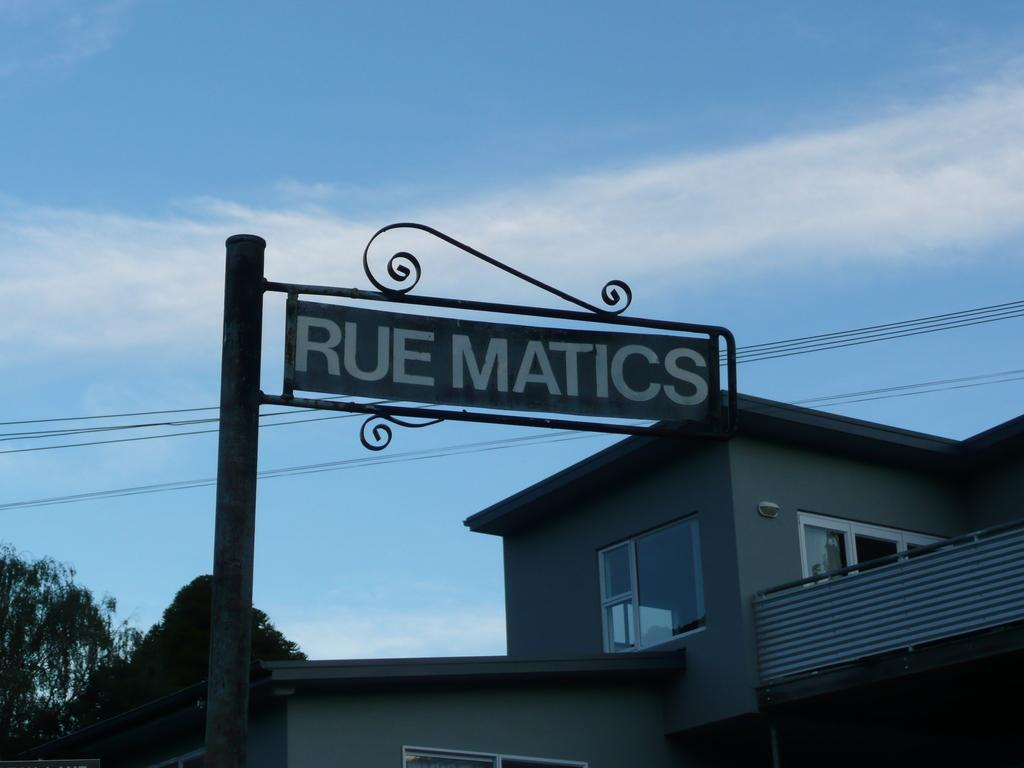What is located in the foreground of the image? There is a pole in the foreground of the image. What structure is visible behind the pole? There is a house behind the pole. What type of vegetation can be seen in the image? Trees are visible in the image. What else is present in the image besides the pole, house, and trees? Cables are present in the image. What is visible at the top of the image? The sky is visible at the top of the image. Can you describe the sky in the image? There is a cloud in the sky. What type of offer is being made by the army in the image? There is no army or offer present in the image. What type of kettle can be seen boiling water in the image? There is no kettle present in the image. 